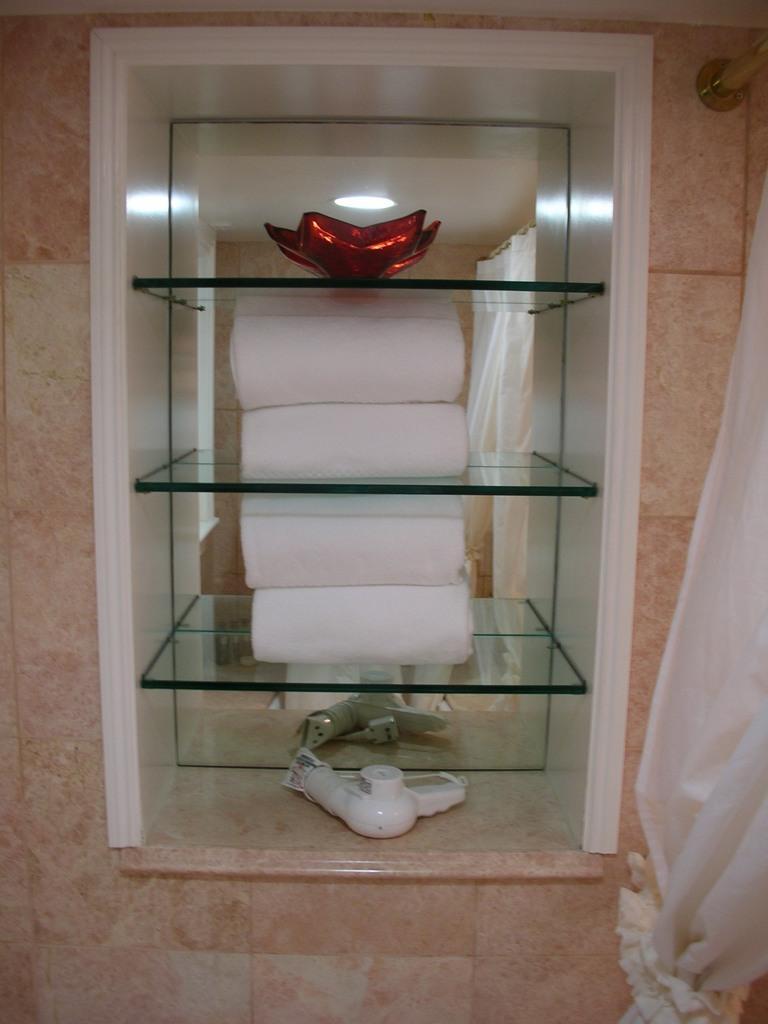In one or two sentences, can you explain what this image depicts? In this picture we can see towels and other things in the shelves, on the right side of the image we can see a metal rod and curtain. 